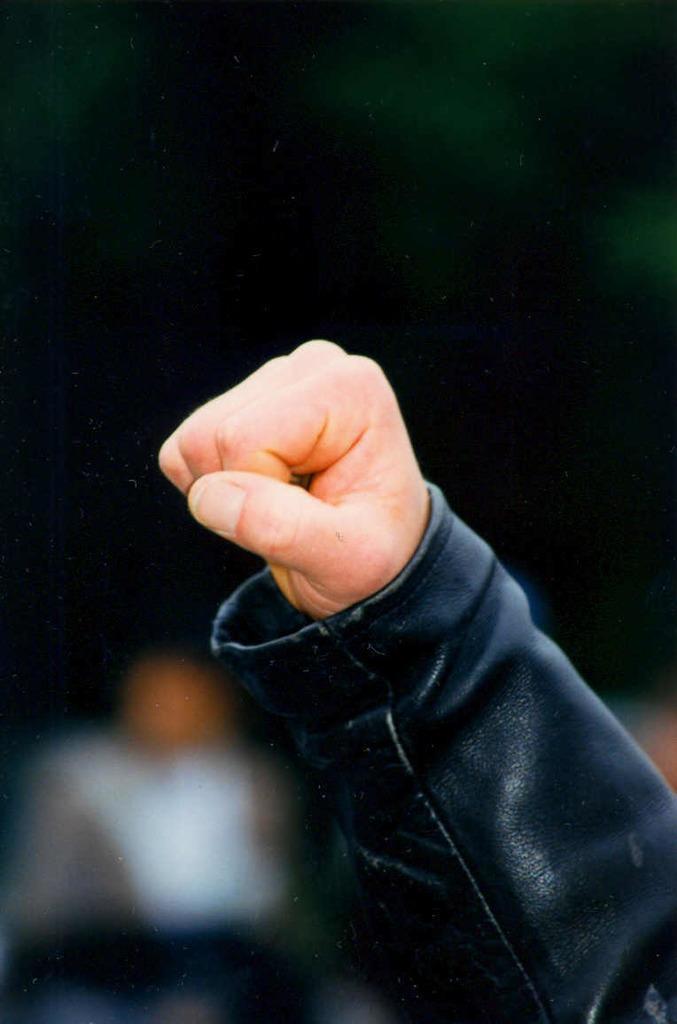How would you summarize this image in a sentence or two? In this image we can see a person's hand. 